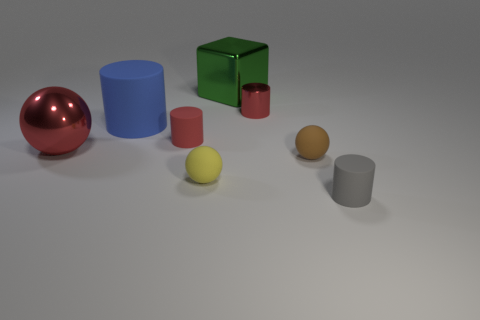Add 1 brown rubber objects. How many objects exist? 9 Subtract all cubes. How many objects are left? 7 Add 4 blue shiny cylinders. How many blue shiny cylinders exist? 4 Subtract 1 brown spheres. How many objects are left? 7 Subtract all brown rubber spheres. Subtract all red spheres. How many objects are left? 6 Add 8 small matte cylinders. How many small matte cylinders are left? 10 